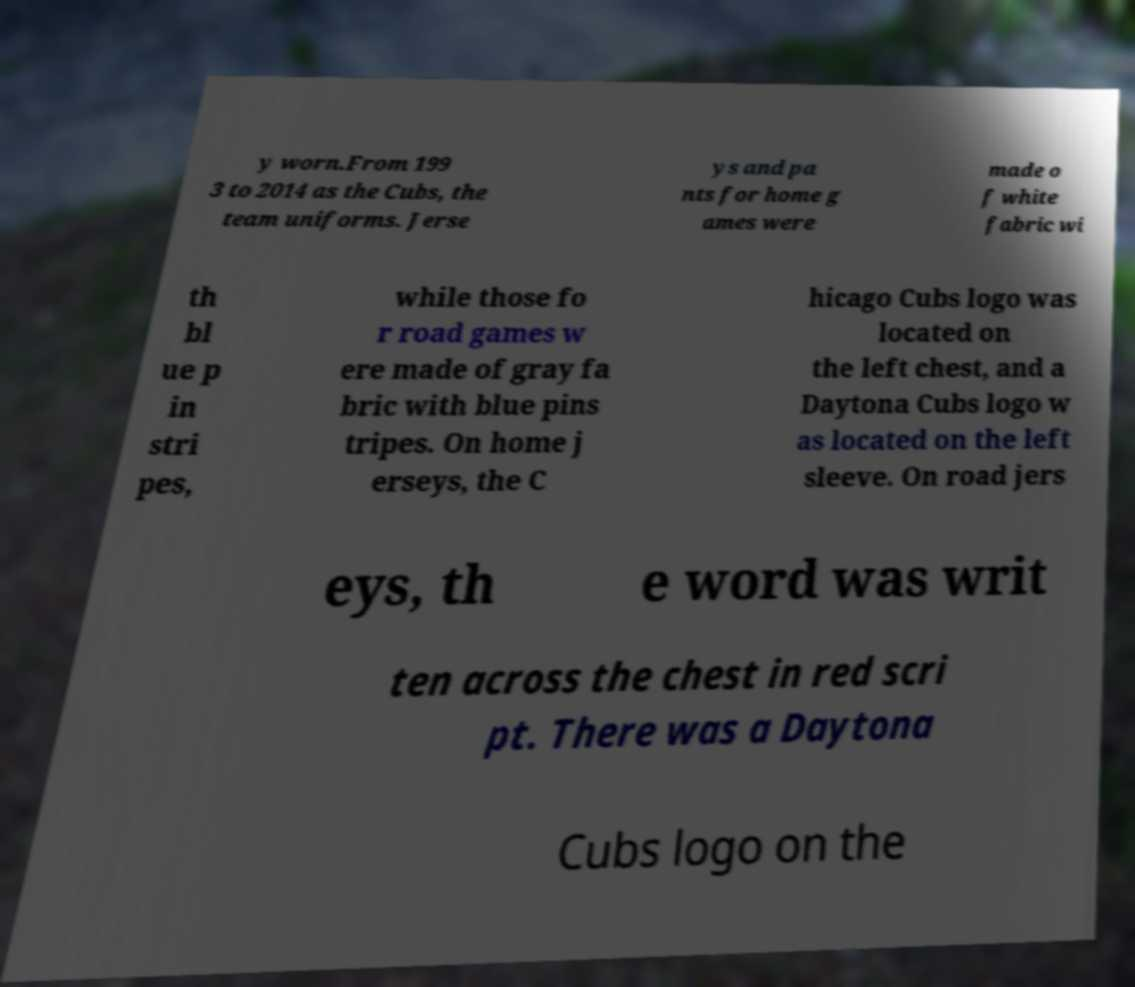Please read and relay the text visible in this image. What does it say? y worn.From 199 3 to 2014 as the Cubs, the team uniforms. Jerse ys and pa nts for home g ames were made o f white fabric wi th bl ue p in stri pes, while those fo r road games w ere made of gray fa bric with blue pins tripes. On home j erseys, the C hicago Cubs logo was located on the left chest, and a Daytona Cubs logo w as located on the left sleeve. On road jers eys, th e word was writ ten across the chest in red scri pt. There was a Daytona Cubs logo on the 